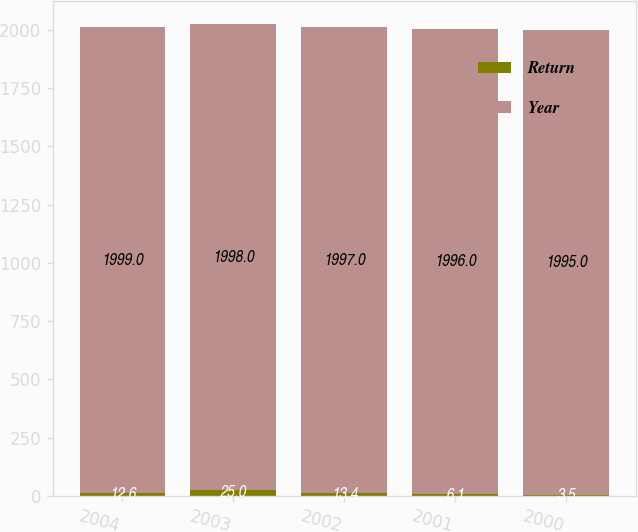<chart> <loc_0><loc_0><loc_500><loc_500><stacked_bar_chart><ecel><fcel>2004<fcel>2003<fcel>2002<fcel>2001<fcel>2000<nl><fcel>Return<fcel>12.6<fcel>25<fcel>13.4<fcel>6.1<fcel>3.5<nl><fcel>Year<fcel>1999<fcel>1998<fcel>1997<fcel>1996<fcel>1995<nl></chart> 